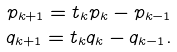Convert formula to latex. <formula><loc_0><loc_0><loc_500><loc_500>p _ { k + 1 } = t _ { k } p _ { k } - p _ { k - 1 } \\ q _ { k + 1 } = t _ { k } q _ { k } - q _ { k - 1 } .</formula> 